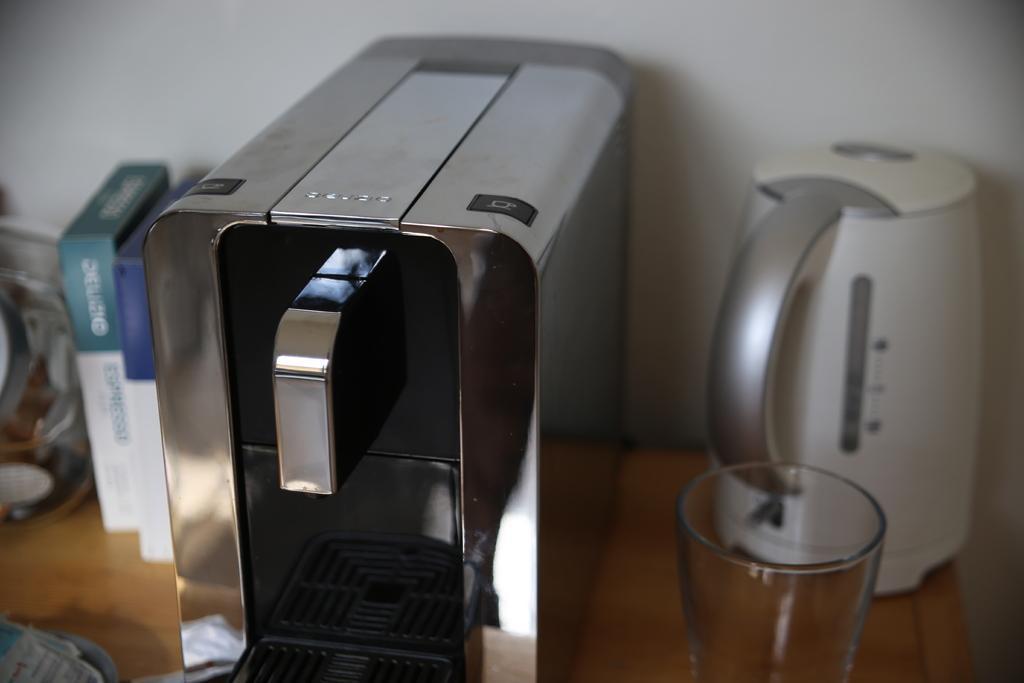Could you give a brief overview of what you see in this image? In this picture I can see a machine, kettle, glass and some other objects on the table, and in the background there is a wall. 